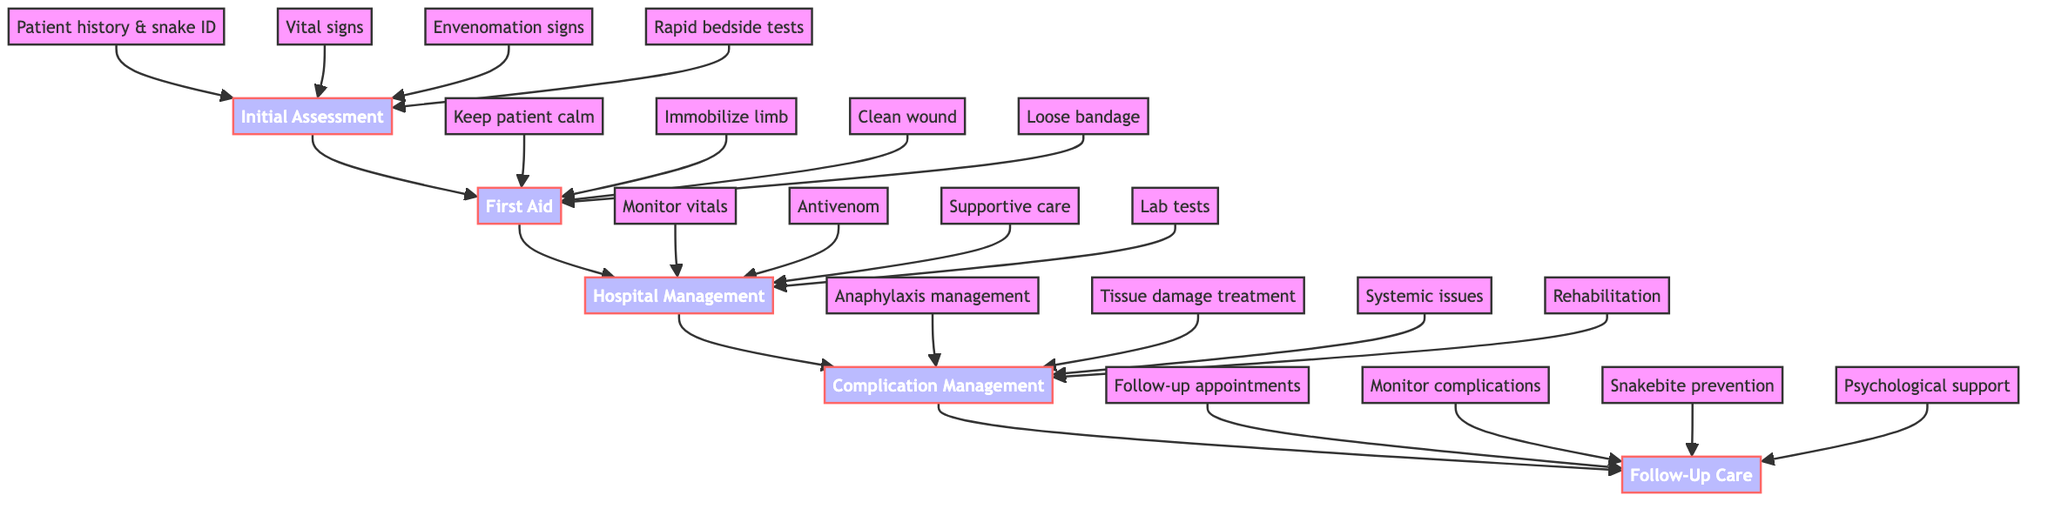What is the first step after Initial Assessment? The diagram shows that the first step following Initial Assessment is First Aid, indicating the successive connection between these phases of treatment.
Answer: First Aid How many steps are in Hospital Management? Counting the steps listed under Hospital Management in the diagram, there are four distinct actions that follow the Hospital Management phase.
Answer: 4 What should be done to the bitten limb according to First Aid? The diagram specifies that during the First Aid phase, one of the steps is to immobilize the bitten limb at approximately heart level, describing a specific action to minimize further injury.
Answer: Immobilize limb What is the last phase of the treatment pathway? The diagram explicitly outlines the sequence of treatment phases, indicating that Follow-Up Care is positioned as the final phase after Complication Management.
Answer: Follow-Up Care Which step addresses systemic issues in snakebite treatment? Within the Complication Management section, the step addressing systemic issues highlights the necessity to manage conditions like renal failure or disseminated intravascular coagulation as complications arising from envenomation.
Answer: Systemic issues What is the primary focus during Initial Assessment? Analyzing the Initial Assessment phase, the primary focus is on evaluating the patient immediately to gather essential information about vital signs and symptoms indicating potential envenomation.
Answer: Evaluate the patient Which group manages anaphylaxis if it occurs? The diagram connects anaphylaxis management to Complication Management, indicating this group is responsible for addressing reactions during the treatment phase when antivenom is used.
Answer: Complication Management What should be monitored in Follow-Up Care? The Follow-Up Care phase emphasizes the importance of monitoring for delayed complications, which is crucial to ensure recovery after snakebite treatment.
Answer: Monitor complications 